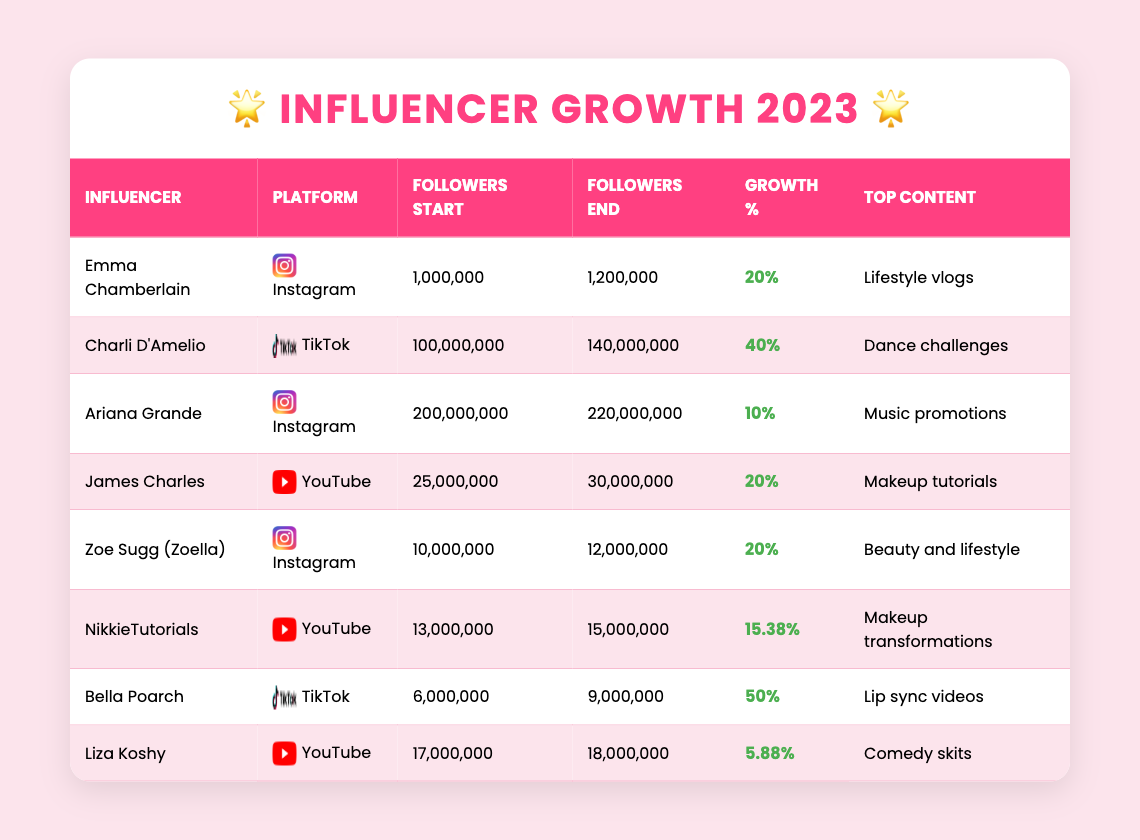What is the highest follower growth percentage? The table shows that Bella Poarch has the highest growth percentage at 50%, as indicated in her row.
Answer: 50% Which influencer gained the least number of followers? Liza Koshy started with 17,000,000 followers and ended with 18,000,000 followers, gaining only 1,000,000, which is the smallest gain in the table.
Answer: Liza Koshy What type of content does Charli D'Amelio focus on? The table specifies that Charli D'Amelio’s top content type is "Dance challenges" in her row.
Answer: Dance challenges How many influencers are primarily on Instagram? By counting the entries under the Instagram platform in the table, we find there are 4 influencers: Emma Chamberlain, Ariana Grande, Zoe Sugg (Zoella), and NikkieTutorials.
Answer: 4 What is the total number of followers gained by all influencers combined? We calculate the gains by subtracting the start followers from the end followers for each influencer: (1,200,000 - 1,000,000) + (140,000,000 - 100,000,000) + (220,000,000 - 200,000,000) + (30,000,000 - 25,000,000) + (12,000,000 - 10,000,000) + (15,000,000 - 13,000,000) + (9,000,000 - 6,000,000) + (18,000,000 - 17,000,000) = 1,000,000 + 40,000,000 + 20,000,000 + 5,000,000 + 2,000,000 + 2,000,000 + 3,000,000 + 1,000,000 = 74,000,000.
Answer: 74,000,000 Is NikkieTutorials' growth percentage higher than Ariana Grande's? NikkieTutorials' growth percentage is 15.38%, while Ariana Grande's is 10%, which is lower, so NikkieTutorials' growth is indeed higher.
Answer: Yes Who is the most popular influencer at the start of the year? By checking the followers at the start, Charli D'Amelio has the most followers with 100,000,000 at the start of the year.
Answer: Charli D'Amelio What percentage growth does Zoe Sugg (Zoella) have compared to Bella Poarch? Zoe Sugg (Zoella) has a 20% growth while Bella Poarch has a 50% growth, so we observe that Bella Poarch's growth is 30% higher than Zoe Sugg (Zoella).
Answer: 30% higher What is the average growth percentage of all influencers listed? To find the average, we sum the growth percentages (20 + 40 + 10 + 20 + 20 + 15.38 + 50 + 5.88) = 182.26, then divide by the number of influencers (8): 182.26 / 8 = 22.78.
Answer: 22.78 Are there any influencers who gained exactly 20% in follower growth? Yes, Emma Chamberlain, James Charles, and Zoe Sugg (Zoella) all reported a 20% growth in followers.
Answer: Yes What type of content does Emma Chamberlain primarily create? The table indicates that Emma Chamberlain focuses primarily on "Lifestyle vlogs."
Answer: Lifestyle vlogs 